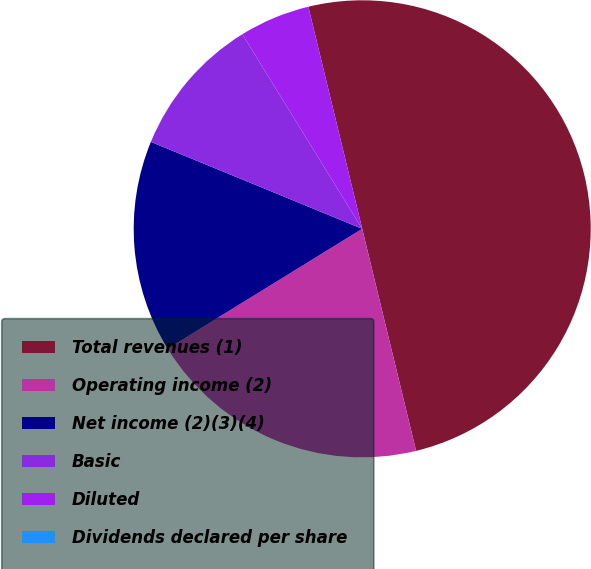<chart> <loc_0><loc_0><loc_500><loc_500><pie_chart><fcel>Total revenues (1)<fcel>Operating income (2)<fcel>Net income (2)(3)(4)<fcel>Basic<fcel>Diluted<fcel>Dividends declared per share<nl><fcel>50.0%<fcel>20.0%<fcel>15.0%<fcel>10.0%<fcel>5.0%<fcel>0.0%<nl></chart> 